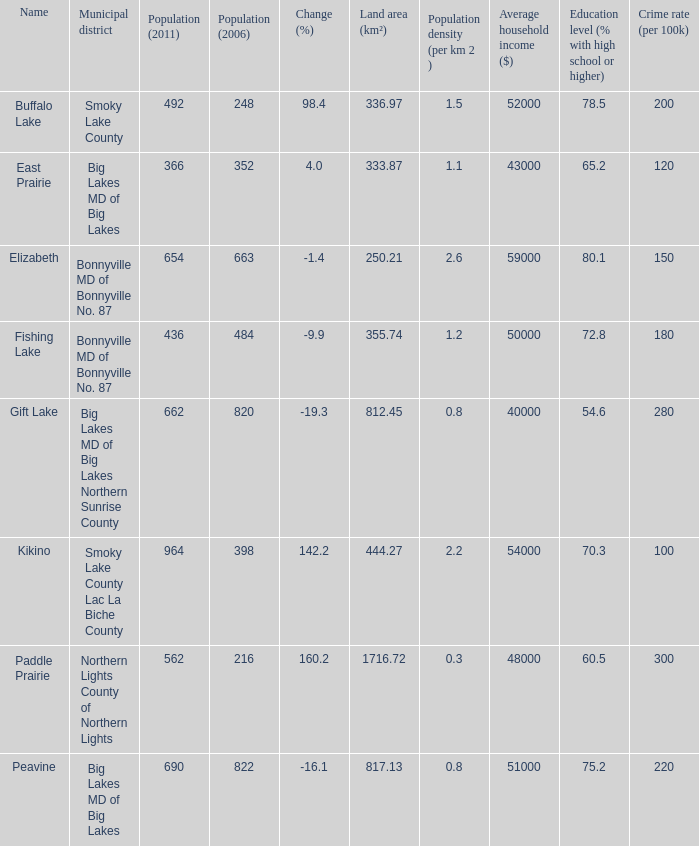What is the population per km2 in Fishing Lake? 1.2. Could you help me parse every detail presented in this table? {'header': ['Name', 'Municipal district', 'Population (2011)', 'Population (2006)', 'Change (%)', 'Land area (km²)', 'Population density (per km 2 )', 'Average household income ($)', 'Education level (% with high school or higher)', 'Crime rate (per 100k)'], 'rows': [['Buffalo Lake', 'Smoky Lake County', '492', '248', '98.4', '336.97', '1.5', '52000', '78.5', '200'], ['East Prairie', 'Big Lakes MD of Big Lakes', '366', '352', '4.0', '333.87', '1.1', '43000', '65.2', '120'], ['Elizabeth', 'Bonnyville MD of Bonnyville No. 87', '654', '663', '-1.4', '250.21', '2.6', '59000', '80.1', '150'], ['Fishing Lake', 'Bonnyville MD of Bonnyville No. 87', '436', '484', '-9.9', '355.74', '1.2', '50000', '72.8', '180'], ['Gift Lake', 'Big Lakes MD of Big Lakes Northern Sunrise County', '662', '820', '-19.3', '812.45', '0.8', '40000', '54.6', '280'], ['Kikino', 'Smoky Lake County Lac La Biche County', '964', '398', '142.2', '444.27', '2.2', '54000', '70.3', '100'], ['Paddle Prairie', 'Northern Lights County of Northern Lights', '562', '216', '160.2', '1716.72', '0.3', '48000', '60.5', '300'], ['Peavine', 'Big Lakes MD of Big Lakes', '690', '822', '-16.1', '817.13', '0.8', '51000', '75.2', '220']]} 